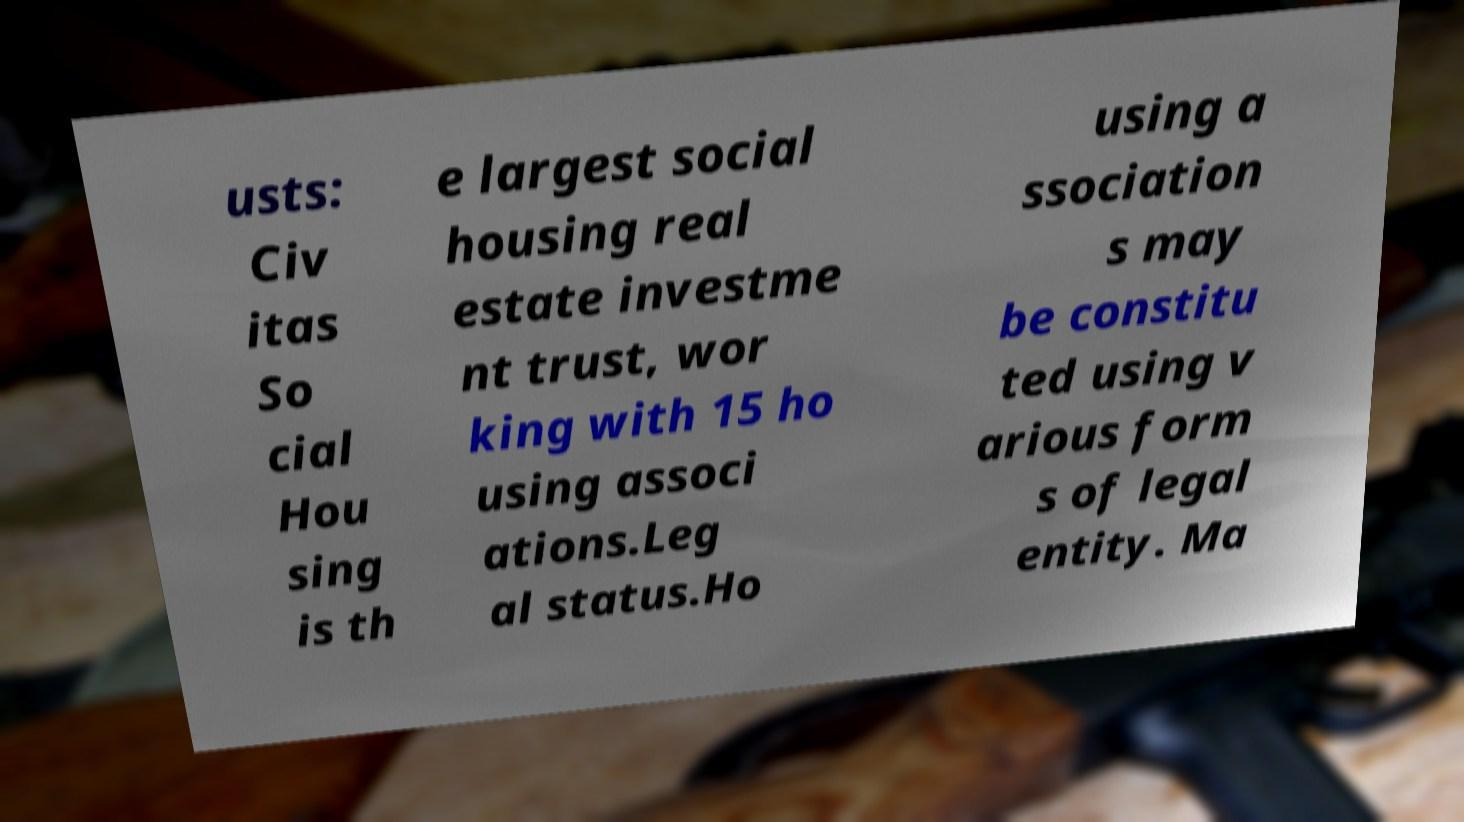I need the written content from this picture converted into text. Can you do that? usts: Civ itas So cial Hou sing is th e largest social housing real estate investme nt trust, wor king with 15 ho using associ ations.Leg al status.Ho using a ssociation s may be constitu ted using v arious form s of legal entity. Ma 